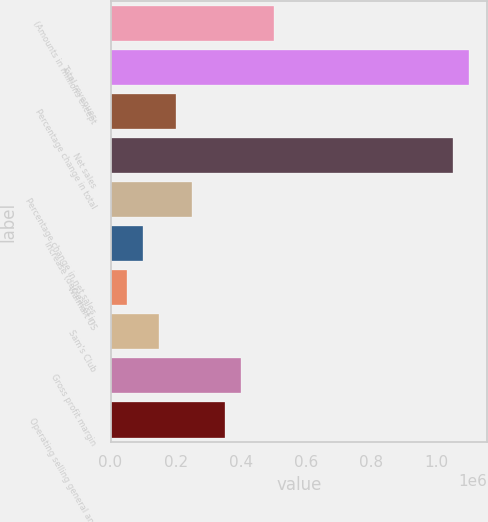Convert chart. <chart><loc_0><loc_0><loc_500><loc_500><bar_chart><fcel>(Amounts in millions except<fcel>Total revenues<fcel>Percentage change in total<fcel>Net sales<fcel>Percentage change in net sales<fcel>Increase (decrease) in<fcel>Walmart US<fcel>Sam's Club<fcel>Gross profit margin<fcel>Operating selling general and<nl><fcel>500343<fcel>1.10075e+06<fcel>200138<fcel>1.05072e+06<fcel>250173<fcel>100070<fcel>50036.1<fcel>150104<fcel>400275<fcel>350241<nl></chart> 